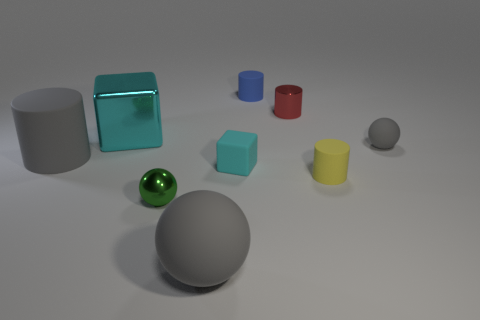How many tiny blue spheres have the same material as the big sphere?
Keep it short and to the point. 0. What is the color of the large cylinder that is the same material as the tiny cyan thing?
Keep it short and to the point. Gray. There is a green metallic thing; what shape is it?
Your answer should be compact. Sphere. How many rubber blocks have the same color as the large metallic block?
Keep it short and to the point. 1. What is the shape of the gray thing that is the same size as the gray matte cylinder?
Keep it short and to the point. Sphere. Are there any yellow matte objects of the same size as the gray cylinder?
Your answer should be very brief. No. What is the material of the red cylinder that is the same size as the blue object?
Your answer should be very brief. Metal. What size is the cube behind the big rubber object that is behind the tiny green thing?
Provide a short and direct response. Large. There is a metallic object that is on the left side of the green thing; does it have the same size as the small red metal cylinder?
Offer a very short reply. No. Is the number of large gray things in front of the small green sphere greater than the number of cyan metal objects right of the blue rubber cylinder?
Offer a terse response. Yes. 